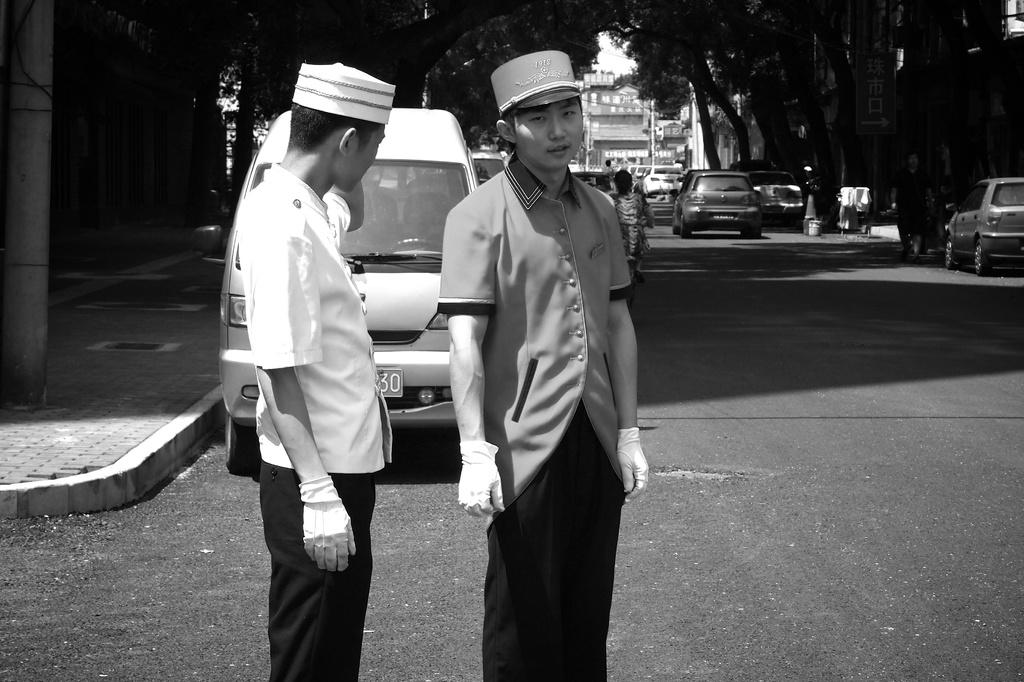How many men are present in the image? There are two men standing in the image. What can be seen on the road in the image? There are vehicles on the road in the image. What is located on the left side of the image? There is a pole on the left side of the image. What type of scenery is visible in the background of the image? There are trees and buildings in the background of the image. What type of pie is displayed on the shelf in the image? There is no pie or shelf present in the image. 